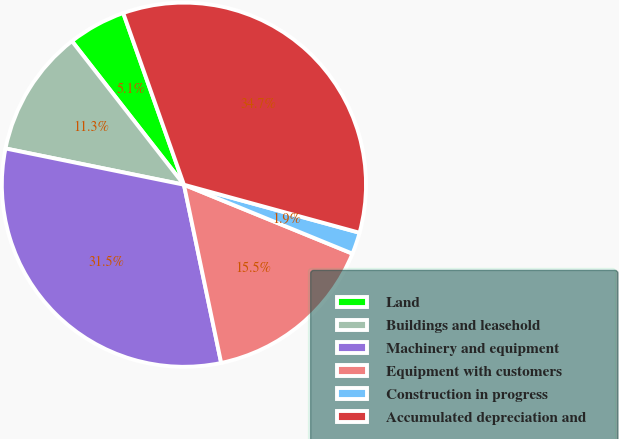<chart> <loc_0><loc_0><loc_500><loc_500><pie_chart><fcel>Land<fcel>Buildings and leasehold<fcel>Machinery and equipment<fcel>Equipment with customers<fcel>Construction in progress<fcel>Accumulated depreciation and<nl><fcel>5.13%<fcel>11.27%<fcel>31.47%<fcel>15.54%<fcel>1.93%<fcel>34.66%<nl></chart> 